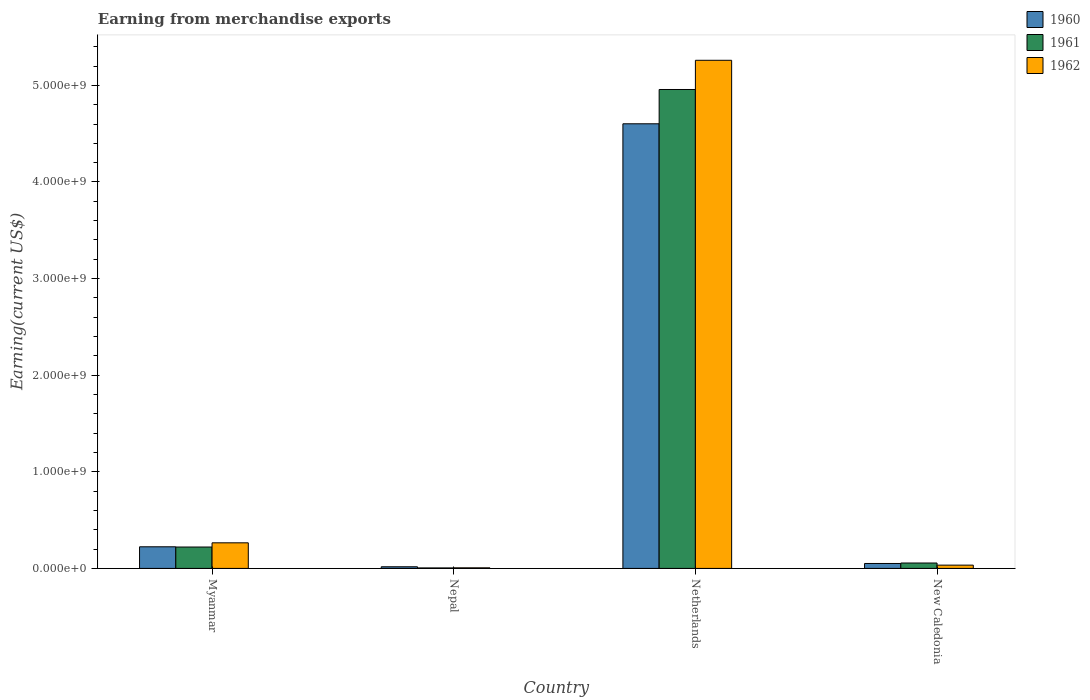How many bars are there on the 2nd tick from the right?
Your answer should be very brief. 3. What is the label of the 2nd group of bars from the left?
Ensure brevity in your answer.  Nepal. What is the amount earned from merchandise exports in 1962 in New Caledonia?
Give a very brief answer. 3.40e+07. Across all countries, what is the maximum amount earned from merchandise exports in 1960?
Keep it short and to the point. 4.60e+09. In which country was the amount earned from merchandise exports in 1961 minimum?
Make the answer very short. Nepal. What is the total amount earned from merchandise exports in 1962 in the graph?
Give a very brief answer. 5.56e+09. What is the difference between the amount earned from merchandise exports in 1961 in Myanmar and that in Nepal?
Keep it short and to the point. 2.16e+08. What is the difference between the amount earned from merchandise exports in 1962 in Nepal and the amount earned from merchandise exports in 1960 in New Caledonia?
Make the answer very short. -4.50e+07. What is the average amount earned from merchandise exports in 1961 per country?
Offer a terse response. 1.31e+09. What is the difference between the amount earned from merchandise exports of/in 1961 and amount earned from merchandise exports of/in 1960 in Nepal?
Your response must be concise. -1.20e+07. What is the ratio of the amount earned from merchandise exports in 1962 in Myanmar to that in New Caledonia?
Provide a short and direct response. 7.79. Is the amount earned from merchandise exports in 1962 in Nepal less than that in Netherlands?
Offer a very short reply. Yes. Is the difference between the amount earned from merchandise exports in 1961 in Myanmar and New Caledonia greater than the difference between the amount earned from merchandise exports in 1960 in Myanmar and New Caledonia?
Provide a succinct answer. No. What is the difference between the highest and the second highest amount earned from merchandise exports in 1961?
Provide a short and direct response. 4.90e+09. What is the difference between the highest and the lowest amount earned from merchandise exports in 1962?
Your answer should be compact. 5.25e+09. In how many countries, is the amount earned from merchandise exports in 1961 greater than the average amount earned from merchandise exports in 1961 taken over all countries?
Your response must be concise. 1. Are all the bars in the graph horizontal?
Your response must be concise. No. Does the graph contain any zero values?
Your answer should be compact. No. Does the graph contain grids?
Your answer should be very brief. No. Where does the legend appear in the graph?
Provide a short and direct response. Top right. How are the legend labels stacked?
Your answer should be compact. Vertical. What is the title of the graph?
Your response must be concise. Earning from merchandise exports. What is the label or title of the X-axis?
Ensure brevity in your answer.  Country. What is the label or title of the Y-axis?
Your response must be concise. Earning(current US$). What is the Earning(current US$) of 1960 in Myanmar?
Your answer should be very brief. 2.24e+08. What is the Earning(current US$) in 1961 in Myanmar?
Your answer should be compact. 2.21e+08. What is the Earning(current US$) of 1962 in Myanmar?
Ensure brevity in your answer.  2.65e+08. What is the Earning(current US$) of 1960 in Nepal?
Ensure brevity in your answer.  1.70e+07. What is the Earning(current US$) of 1961 in Nepal?
Offer a very short reply. 5.00e+06. What is the Earning(current US$) in 1962 in Nepal?
Make the answer very short. 6.00e+06. What is the Earning(current US$) of 1960 in Netherlands?
Give a very brief answer. 4.60e+09. What is the Earning(current US$) of 1961 in Netherlands?
Ensure brevity in your answer.  4.96e+09. What is the Earning(current US$) of 1962 in Netherlands?
Offer a terse response. 5.26e+09. What is the Earning(current US$) of 1960 in New Caledonia?
Offer a terse response. 5.10e+07. What is the Earning(current US$) of 1961 in New Caledonia?
Offer a very short reply. 5.60e+07. What is the Earning(current US$) of 1962 in New Caledonia?
Your answer should be compact. 3.40e+07. Across all countries, what is the maximum Earning(current US$) in 1960?
Make the answer very short. 4.60e+09. Across all countries, what is the maximum Earning(current US$) of 1961?
Provide a short and direct response. 4.96e+09. Across all countries, what is the maximum Earning(current US$) in 1962?
Provide a short and direct response. 5.26e+09. Across all countries, what is the minimum Earning(current US$) of 1960?
Your answer should be very brief. 1.70e+07. Across all countries, what is the minimum Earning(current US$) in 1961?
Make the answer very short. 5.00e+06. Across all countries, what is the minimum Earning(current US$) of 1962?
Your answer should be very brief. 6.00e+06. What is the total Earning(current US$) in 1960 in the graph?
Your response must be concise. 4.89e+09. What is the total Earning(current US$) in 1961 in the graph?
Offer a terse response. 5.24e+09. What is the total Earning(current US$) of 1962 in the graph?
Your answer should be compact. 5.56e+09. What is the difference between the Earning(current US$) in 1960 in Myanmar and that in Nepal?
Your answer should be compact. 2.07e+08. What is the difference between the Earning(current US$) of 1961 in Myanmar and that in Nepal?
Ensure brevity in your answer.  2.16e+08. What is the difference between the Earning(current US$) in 1962 in Myanmar and that in Nepal?
Your answer should be very brief. 2.59e+08. What is the difference between the Earning(current US$) of 1960 in Myanmar and that in Netherlands?
Offer a very short reply. -4.38e+09. What is the difference between the Earning(current US$) of 1961 in Myanmar and that in Netherlands?
Your answer should be compact. -4.74e+09. What is the difference between the Earning(current US$) in 1962 in Myanmar and that in Netherlands?
Keep it short and to the point. -4.99e+09. What is the difference between the Earning(current US$) in 1960 in Myanmar and that in New Caledonia?
Your response must be concise. 1.73e+08. What is the difference between the Earning(current US$) in 1961 in Myanmar and that in New Caledonia?
Ensure brevity in your answer.  1.65e+08. What is the difference between the Earning(current US$) of 1962 in Myanmar and that in New Caledonia?
Keep it short and to the point. 2.31e+08. What is the difference between the Earning(current US$) of 1960 in Nepal and that in Netherlands?
Offer a terse response. -4.59e+09. What is the difference between the Earning(current US$) in 1961 in Nepal and that in Netherlands?
Your answer should be compact. -4.95e+09. What is the difference between the Earning(current US$) in 1962 in Nepal and that in Netherlands?
Your response must be concise. -5.25e+09. What is the difference between the Earning(current US$) in 1960 in Nepal and that in New Caledonia?
Provide a short and direct response. -3.40e+07. What is the difference between the Earning(current US$) of 1961 in Nepal and that in New Caledonia?
Provide a succinct answer. -5.10e+07. What is the difference between the Earning(current US$) in 1962 in Nepal and that in New Caledonia?
Provide a short and direct response. -2.80e+07. What is the difference between the Earning(current US$) of 1960 in Netherlands and that in New Caledonia?
Keep it short and to the point. 4.55e+09. What is the difference between the Earning(current US$) of 1961 in Netherlands and that in New Caledonia?
Provide a short and direct response. 4.90e+09. What is the difference between the Earning(current US$) of 1962 in Netherlands and that in New Caledonia?
Ensure brevity in your answer.  5.23e+09. What is the difference between the Earning(current US$) of 1960 in Myanmar and the Earning(current US$) of 1961 in Nepal?
Offer a very short reply. 2.19e+08. What is the difference between the Earning(current US$) in 1960 in Myanmar and the Earning(current US$) in 1962 in Nepal?
Make the answer very short. 2.18e+08. What is the difference between the Earning(current US$) of 1961 in Myanmar and the Earning(current US$) of 1962 in Nepal?
Your response must be concise. 2.15e+08. What is the difference between the Earning(current US$) of 1960 in Myanmar and the Earning(current US$) of 1961 in Netherlands?
Offer a terse response. -4.73e+09. What is the difference between the Earning(current US$) of 1960 in Myanmar and the Earning(current US$) of 1962 in Netherlands?
Offer a very short reply. -5.04e+09. What is the difference between the Earning(current US$) in 1961 in Myanmar and the Earning(current US$) in 1962 in Netherlands?
Ensure brevity in your answer.  -5.04e+09. What is the difference between the Earning(current US$) in 1960 in Myanmar and the Earning(current US$) in 1961 in New Caledonia?
Offer a terse response. 1.68e+08. What is the difference between the Earning(current US$) of 1960 in Myanmar and the Earning(current US$) of 1962 in New Caledonia?
Make the answer very short. 1.90e+08. What is the difference between the Earning(current US$) of 1961 in Myanmar and the Earning(current US$) of 1962 in New Caledonia?
Keep it short and to the point. 1.87e+08. What is the difference between the Earning(current US$) in 1960 in Nepal and the Earning(current US$) in 1961 in Netherlands?
Offer a terse response. -4.94e+09. What is the difference between the Earning(current US$) of 1960 in Nepal and the Earning(current US$) of 1962 in Netherlands?
Offer a terse response. -5.24e+09. What is the difference between the Earning(current US$) of 1961 in Nepal and the Earning(current US$) of 1962 in Netherlands?
Give a very brief answer. -5.25e+09. What is the difference between the Earning(current US$) of 1960 in Nepal and the Earning(current US$) of 1961 in New Caledonia?
Provide a succinct answer. -3.90e+07. What is the difference between the Earning(current US$) of 1960 in Nepal and the Earning(current US$) of 1962 in New Caledonia?
Provide a short and direct response. -1.70e+07. What is the difference between the Earning(current US$) in 1961 in Nepal and the Earning(current US$) in 1962 in New Caledonia?
Your answer should be compact. -2.90e+07. What is the difference between the Earning(current US$) of 1960 in Netherlands and the Earning(current US$) of 1961 in New Caledonia?
Give a very brief answer. 4.55e+09. What is the difference between the Earning(current US$) in 1960 in Netherlands and the Earning(current US$) in 1962 in New Caledonia?
Provide a short and direct response. 4.57e+09. What is the difference between the Earning(current US$) in 1961 in Netherlands and the Earning(current US$) in 1962 in New Caledonia?
Make the answer very short. 4.92e+09. What is the average Earning(current US$) in 1960 per country?
Keep it short and to the point. 1.22e+09. What is the average Earning(current US$) of 1961 per country?
Your answer should be very brief. 1.31e+09. What is the average Earning(current US$) of 1962 per country?
Your answer should be compact. 1.39e+09. What is the difference between the Earning(current US$) of 1960 and Earning(current US$) of 1961 in Myanmar?
Provide a succinct answer. 2.42e+06. What is the difference between the Earning(current US$) in 1960 and Earning(current US$) in 1962 in Myanmar?
Give a very brief answer. -4.11e+07. What is the difference between the Earning(current US$) of 1961 and Earning(current US$) of 1962 in Myanmar?
Offer a very short reply. -4.35e+07. What is the difference between the Earning(current US$) of 1960 and Earning(current US$) of 1961 in Nepal?
Offer a terse response. 1.20e+07. What is the difference between the Earning(current US$) of 1960 and Earning(current US$) of 1962 in Nepal?
Offer a terse response. 1.10e+07. What is the difference between the Earning(current US$) in 1961 and Earning(current US$) in 1962 in Nepal?
Offer a very short reply. -1.00e+06. What is the difference between the Earning(current US$) of 1960 and Earning(current US$) of 1961 in Netherlands?
Your response must be concise. -3.55e+08. What is the difference between the Earning(current US$) in 1960 and Earning(current US$) in 1962 in Netherlands?
Offer a terse response. -6.57e+08. What is the difference between the Earning(current US$) of 1961 and Earning(current US$) of 1962 in Netherlands?
Offer a very short reply. -3.02e+08. What is the difference between the Earning(current US$) of 1960 and Earning(current US$) of 1961 in New Caledonia?
Your answer should be compact. -5.00e+06. What is the difference between the Earning(current US$) of 1960 and Earning(current US$) of 1962 in New Caledonia?
Your answer should be compact. 1.70e+07. What is the difference between the Earning(current US$) in 1961 and Earning(current US$) in 1962 in New Caledonia?
Make the answer very short. 2.20e+07. What is the ratio of the Earning(current US$) of 1960 in Myanmar to that in Nepal?
Your response must be concise. 13.16. What is the ratio of the Earning(current US$) of 1961 in Myanmar to that in Nepal?
Keep it short and to the point. 44.27. What is the ratio of the Earning(current US$) of 1962 in Myanmar to that in Nepal?
Offer a terse response. 44.14. What is the ratio of the Earning(current US$) in 1960 in Myanmar to that in Netherlands?
Make the answer very short. 0.05. What is the ratio of the Earning(current US$) in 1961 in Myanmar to that in Netherlands?
Your answer should be very brief. 0.04. What is the ratio of the Earning(current US$) in 1962 in Myanmar to that in Netherlands?
Your response must be concise. 0.05. What is the ratio of the Earning(current US$) of 1960 in Myanmar to that in New Caledonia?
Ensure brevity in your answer.  4.39. What is the ratio of the Earning(current US$) of 1961 in Myanmar to that in New Caledonia?
Offer a very short reply. 3.95. What is the ratio of the Earning(current US$) of 1962 in Myanmar to that in New Caledonia?
Your answer should be very brief. 7.79. What is the ratio of the Earning(current US$) of 1960 in Nepal to that in Netherlands?
Provide a succinct answer. 0. What is the ratio of the Earning(current US$) of 1962 in Nepal to that in Netherlands?
Offer a very short reply. 0. What is the ratio of the Earning(current US$) of 1960 in Nepal to that in New Caledonia?
Provide a succinct answer. 0.33. What is the ratio of the Earning(current US$) of 1961 in Nepal to that in New Caledonia?
Offer a terse response. 0.09. What is the ratio of the Earning(current US$) in 1962 in Nepal to that in New Caledonia?
Offer a very short reply. 0.18. What is the ratio of the Earning(current US$) of 1960 in Netherlands to that in New Caledonia?
Ensure brevity in your answer.  90.24. What is the ratio of the Earning(current US$) of 1961 in Netherlands to that in New Caledonia?
Your response must be concise. 88.52. What is the ratio of the Earning(current US$) of 1962 in Netherlands to that in New Caledonia?
Provide a succinct answer. 154.7. What is the difference between the highest and the second highest Earning(current US$) in 1960?
Make the answer very short. 4.38e+09. What is the difference between the highest and the second highest Earning(current US$) of 1961?
Offer a very short reply. 4.74e+09. What is the difference between the highest and the second highest Earning(current US$) of 1962?
Your answer should be very brief. 4.99e+09. What is the difference between the highest and the lowest Earning(current US$) of 1960?
Your answer should be compact. 4.59e+09. What is the difference between the highest and the lowest Earning(current US$) in 1961?
Make the answer very short. 4.95e+09. What is the difference between the highest and the lowest Earning(current US$) in 1962?
Give a very brief answer. 5.25e+09. 